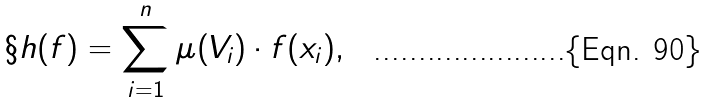<formula> <loc_0><loc_0><loc_500><loc_500>\S h ( f ) = \sum _ { i = 1 } ^ { n } \mu ( V _ { i } ) \cdot f ( x _ { i } ) ,</formula> 